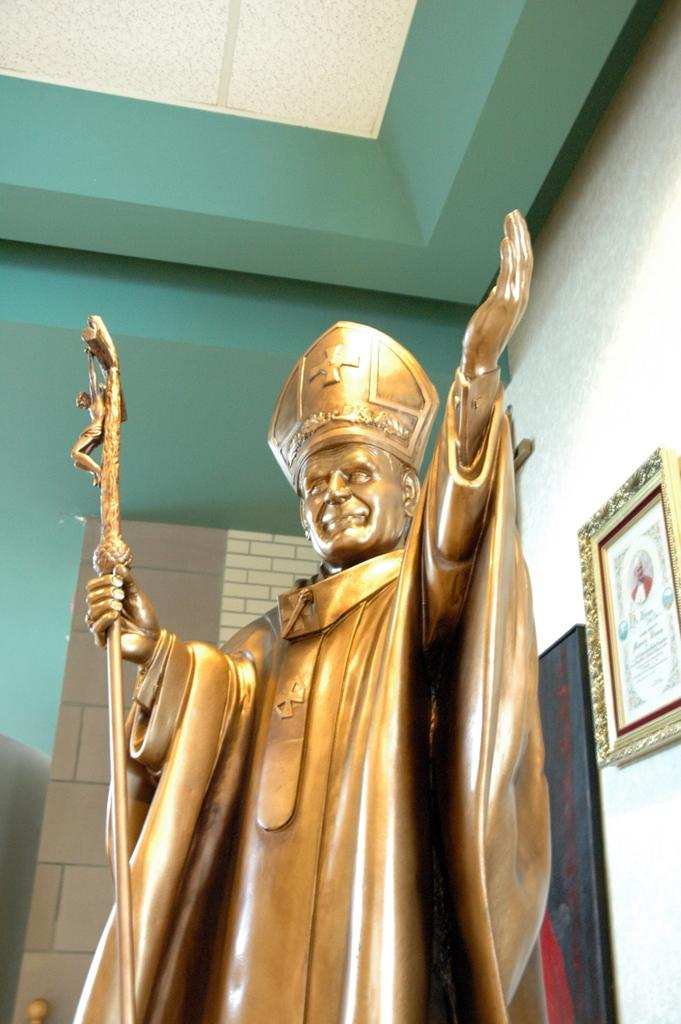What is the main subject of the image? There is a statue of a person in the image. What is the person holding in his hand? The person is holding a stick in his hand. Can you describe any other objects or features in the image? There is a photo frame attached to the wall in the right corner of the image. How does the shoe connect to the statue in the image? There is no shoe present in the image, so it cannot be connected to the statue. 